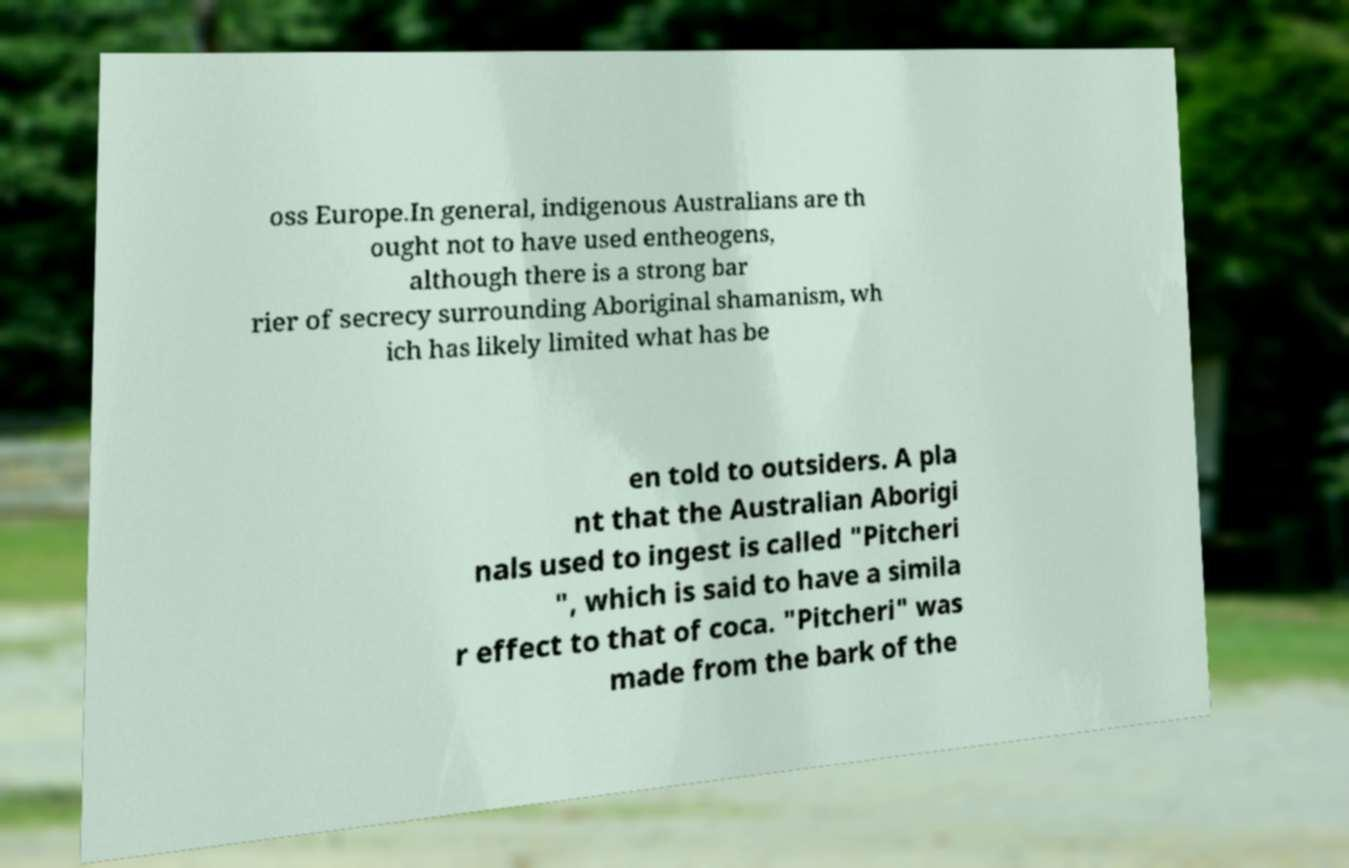Please read and relay the text visible in this image. What does it say? oss Europe.In general, indigenous Australians are th ought not to have used entheogens, although there is a strong bar rier of secrecy surrounding Aboriginal shamanism, wh ich has likely limited what has be en told to outsiders. A pla nt that the Australian Aborigi nals used to ingest is called "Pitcheri ", which is said to have a simila r effect to that of coca. "Pitcheri" was made from the bark of the 